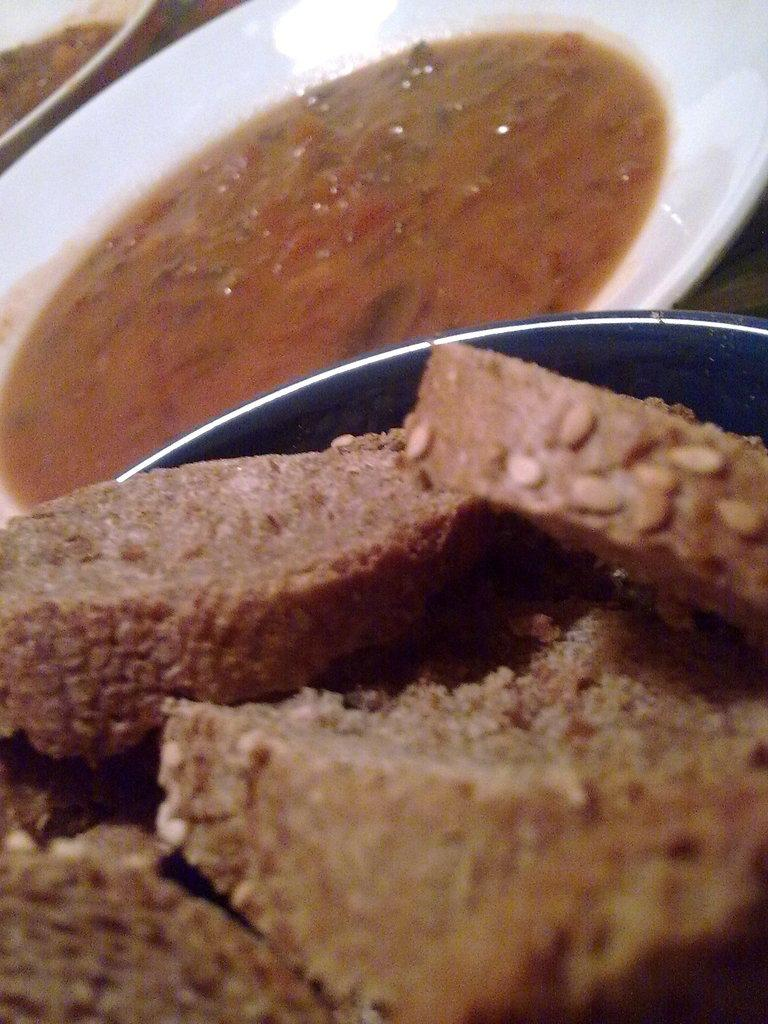What is the main object in the center of the image? There is a table in the center of the image. What is depicted on the table? There are planets depicted on the table. What else can be found on the table? There is a bowl and food items on the table. What type of bear can be seen supporting the planets on the table? There is no bear present in the image, and the planets are not being supported by any creature or object. 